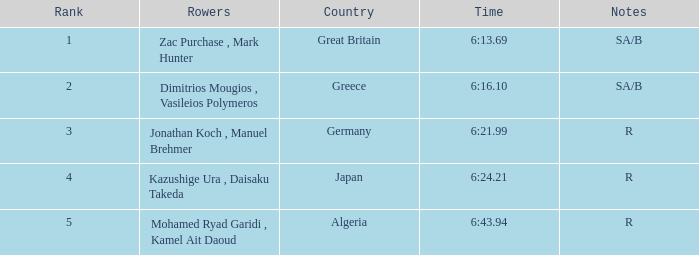21? R. 